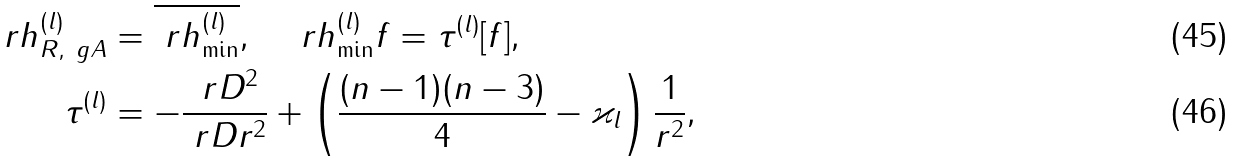Convert formula to latex. <formula><loc_0><loc_0><loc_500><loc_500>\ r h _ { R , \ g A } ^ { ( l ) } & = \overline { \ r h _ { \min } ^ { ( l ) } } , \quad \ r h _ { \min } ^ { ( l ) } f = \tau ^ { ( l ) } [ f ] , \\ \tau ^ { ( l ) } & = - \frac { \ r D ^ { 2 } } { \ r D r ^ { 2 } } + \left ( \frac { ( n - 1 ) ( n - 3 ) } { 4 } - \varkappa _ { l } \right ) \frac { 1 } { r ^ { 2 } } ,</formula> 